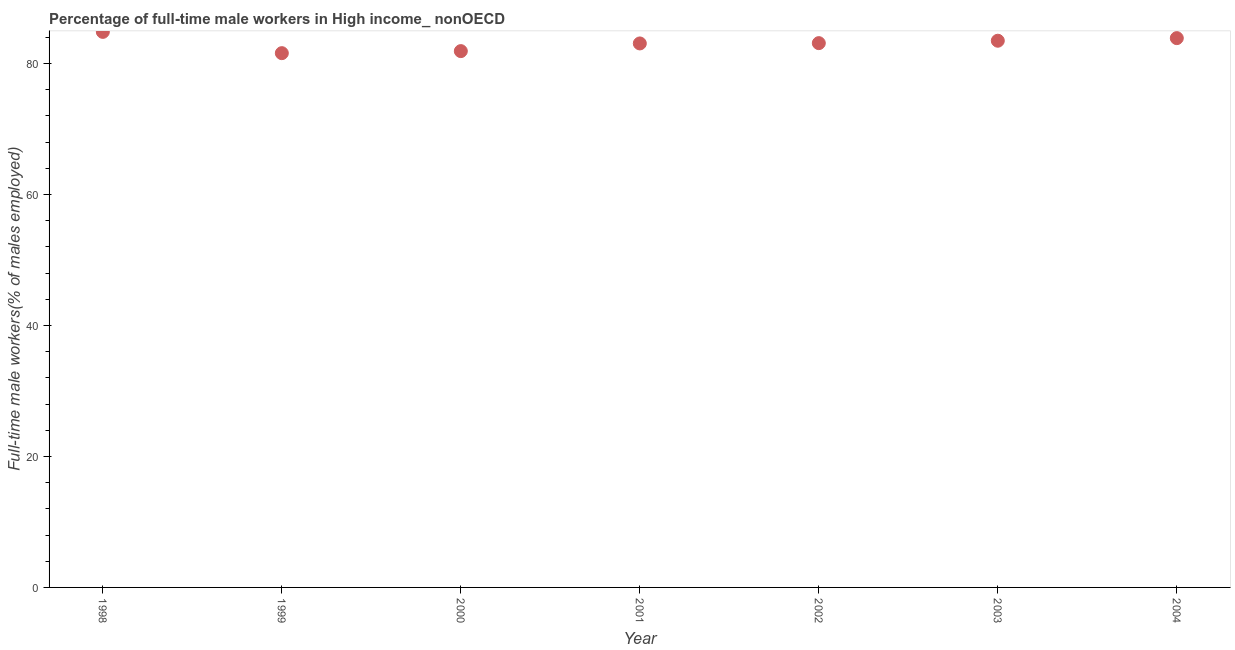What is the percentage of full-time male workers in 1998?
Make the answer very short. 84.84. Across all years, what is the maximum percentage of full-time male workers?
Ensure brevity in your answer.  84.84. Across all years, what is the minimum percentage of full-time male workers?
Provide a short and direct response. 81.59. What is the sum of the percentage of full-time male workers?
Offer a terse response. 581.9. What is the difference between the percentage of full-time male workers in 1998 and 2003?
Give a very brief answer. 1.35. What is the average percentage of full-time male workers per year?
Your response must be concise. 83.13. What is the median percentage of full-time male workers?
Offer a terse response. 83.12. What is the ratio of the percentage of full-time male workers in 1999 to that in 2004?
Make the answer very short. 0.97. Is the difference between the percentage of full-time male workers in 1998 and 1999 greater than the difference between any two years?
Your answer should be very brief. Yes. What is the difference between the highest and the second highest percentage of full-time male workers?
Offer a terse response. 0.95. Is the sum of the percentage of full-time male workers in 2000 and 2002 greater than the maximum percentage of full-time male workers across all years?
Make the answer very short. Yes. What is the difference between the highest and the lowest percentage of full-time male workers?
Offer a terse response. 3.25. In how many years, is the percentage of full-time male workers greater than the average percentage of full-time male workers taken over all years?
Give a very brief answer. 3. Does the graph contain grids?
Your answer should be very brief. No. What is the title of the graph?
Ensure brevity in your answer.  Percentage of full-time male workers in High income_ nonOECD. What is the label or title of the Y-axis?
Make the answer very short. Full-time male workers(% of males employed). What is the Full-time male workers(% of males employed) in 1998?
Your answer should be compact. 84.84. What is the Full-time male workers(% of males employed) in 1999?
Keep it short and to the point. 81.59. What is the Full-time male workers(% of males employed) in 2000?
Offer a terse response. 81.9. What is the Full-time male workers(% of males employed) in 2001?
Give a very brief answer. 83.07. What is the Full-time male workers(% of males employed) in 2002?
Ensure brevity in your answer.  83.12. What is the Full-time male workers(% of males employed) in 2003?
Offer a terse response. 83.49. What is the Full-time male workers(% of males employed) in 2004?
Provide a short and direct response. 83.88. What is the difference between the Full-time male workers(% of males employed) in 1998 and 1999?
Your answer should be very brief. 3.25. What is the difference between the Full-time male workers(% of males employed) in 1998 and 2000?
Offer a terse response. 2.94. What is the difference between the Full-time male workers(% of males employed) in 1998 and 2001?
Provide a short and direct response. 1.76. What is the difference between the Full-time male workers(% of males employed) in 1998 and 2002?
Provide a short and direct response. 1.72. What is the difference between the Full-time male workers(% of males employed) in 1998 and 2003?
Provide a short and direct response. 1.35. What is the difference between the Full-time male workers(% of males employed) in 1998 and 2004?
Make the answer very short. 0.95. What is the difference between the Full-time male workers(% of males employed) in 1999 and 2000?
Provide a succinct answer. -0.31. What is the difference between the Full-time male workers(% of males employed) in 1999 and 2001?
Give a very brief answer. -1.48. What is the difference between the Full-time male workers(% of males employed) in 1999 and 2002?
Keep it short and to the point. -1.53. What is the difference between the Full-time male workers(% of males employed) in 1999 and 2003?
Your answer should be compact. -1.9. What is the difference between the Full-time male workers(% of males employed) in 1999 and 2004?
Keep it short and to the point. -2.3. What is the difference between the Full-time male workers(% of males employed) in 2000 and 2001?
Ensure brevity in your answer.  -1.17. What is the difference between the Full-time male workers(% of males employed) in 2000 and 2002?
Ensure brevity in your answer.  -1.22. What is the difference between the Full-time male workers(% of males employed) in 2000 and 2003?
Offer a very short reply. -1.59. What is the difference between the Full-time male workers(% of males employed) in 2000 and 2004?
Offer a terse response. -1.98. What is the difference between the Full-time male workers(% of males employed) in 2001 and 2002?
Provide a short and direct response. -0.05. What is the difference between the Full-time male workers(% of males employed) in 2001 and 2003?
Give a very brief answer. -0.41. What is the difference between the Full-time male workers(% of males employed) in 2001 and 2004?
Ensure brevity in your answer.  -0.81. What is the difference between the Full-time male workers(% of males employed) in 2002 and 2003?
Make the answer very short. -0.37. What is the difference between the Full-time male workers(% of males employed) in 2002 and 2004?
Give a very brief answer. -0.76. What is the difference between the Full-time male workers(% of males employed) in 2003 and 2004?
Offer a terse response. -0.4. What is the ratio of the Full-time male workers(% of males employed) in 1998 to that in 2000?
Keep it short and to the point. 1.04. What is the ratio of the Full-time male workers(% of males employed) in 1999 to that in 2000?
Provide a succinct answer. 1. What is the ratio of the Full-time male workers(% of males employed) in 1999 to that in 2002?
Provide a short and direct response. 0.98. What is the ratio of the Full-time male workers(% of males employed) in 2001 to that in 2003?
Your response must be concise. 0.99. What is the ratio of the Full-time male workers(% of males employed) in 2001 to that in 2004?
Give a very brief answer. 0.99. What is the ratio of the Full-time male workers(% of males employed) in 2002 to that in 2004?
Your answer should be very brief. 0.99. What is the ratio of the Full-time male workers(% of males employed) in 2003 to that in 2004?
Your response must be concise. 0.99. 